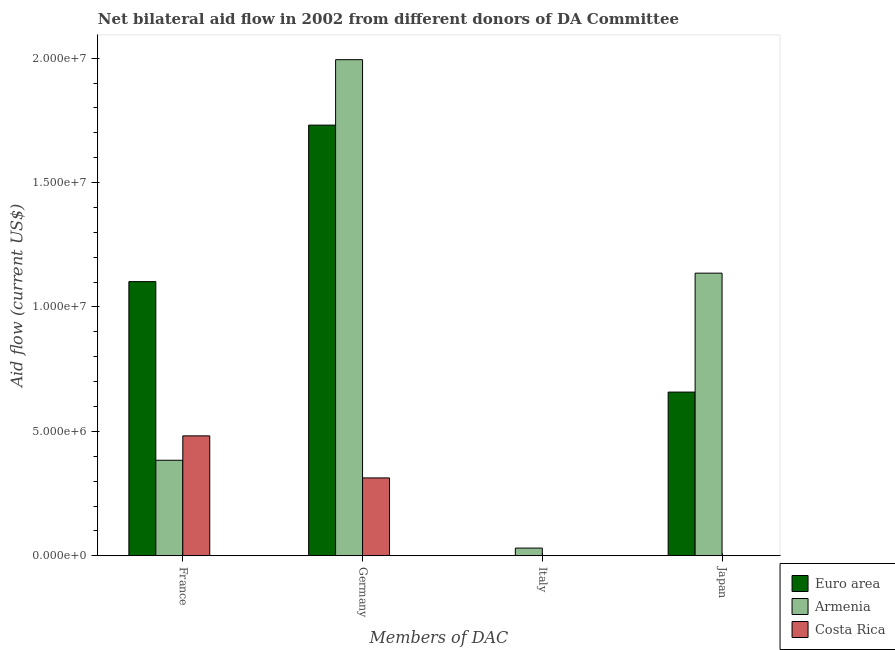How many bars are there on the 3rd tick from the left?
Keep it short and to the point. 1. How many bars are there on the 3rd tick from the right?
Provide a short and direct response. 3. What is the amount of aid given by japan in Euro area?
Provide a succinct answer. 6.58e+06. Across all countries, what is the maximum amount of aid given by japan?
Offer a very short reply. 1.14e+07. In which country was the amount of aid given by japan maximum?
Your answer should be compact. Armenia. What is the total amount of aid given by japan in the graph?
Provide a short and direct response. 1.79e+07. What is the difference between the amount of aid given by germany in Armenia and that in Costa Rica?
Provide a short and direct response. 1.68e+07. What is the difference between the amount of aid given by japan in Armenia and the amount of aid given by france in Costa Rica?
Keep it short and to the point. 6.54e+06. What is the average amount of aid given by japan per country?
Provide a short and direct response. 5.98e+06. What is the difference between the amount of aid given by germany and amount of aid given by japan in Armenia?
Your answer should be compact. 8.58e+06. In how many countries, is the amount of aid given by france greater than 11000000 US$?
Your answer should be very brief. 1. What is the ratio of the amount of aid given by germany in Armenia to that in Euro area?
Offer a very short reply. 1.15. What is the difference between the highest and the second highest amount of aid given by germany?
Provide a succinct answer. 2.63e+06. What is the difference between the highest and the lowest amount of aid given by germany?
Make the answer very short. 1.68e+07. In how many countries, is the amount of aid given by france greater than the average amount of aid given by france taken over all countries?
Your answer should be compact. 1. How many bars are there?
Offer a terse response. 9. Are all the bars in the graph horizontal?
Offer a very short reply. No. Are the values on the major ticks of Y-axis written in scientific E-notation?
Provide a succinct answer. Yes. Where does the legend appear in the graph?
Ensure brevity in your answer.  Bottom right. What is the title of the graph?
Provide a succinct answer. Net bilateral aid flow in 2002 from different donors of DA Committee. Does "Austria" appear as one of the legend labels in the graph?
Provide a short and direct response. No. What is the label or title of the X-axis?
Make the answer very short. Members of DAC. What is the label or title of the Y-axis?
Make the answer very short. Aid flow (current US$). What is the Aid flow (current US$) of Euro area in France?
Ensure brevity in your answer.  1.10e+07. What is the Aid flow (current US$) in Armenia in France?
Offer a very short reply. 3.84e+06. What is the Aid flow (current US$) in Costa Rica in France?
Give a very brief answer. 4.82e+06. What is the Aid flow (current US$) in Euro area in Germany?
Ensure brevity in your answer.  1.73e+07. What is the Aid flow (current US$) in Armenia in Germany?
Make the answer very short. 1.99e+07. What is the Aid flow (current US$) of Costa Rica in Germany?
Give a very brief answer. 3.13e+06. What is the Aid flow (current US$) of Euro area in Italy?
Keep it short and to the point. 0. What is the Aid flow (current US$) of Costa Rica in Italy?
Your answer should be compact. 0. What is the Aid flow (current US$) of Euro area in Japan?
Ensure brevity in your answer.  6.58e+06. What is the Aid flow (current US$) in Armenia in Japan?
Ensure brevity in your answer.  1.14e+07. What is the Aid flow (current US$) in Costa Rica in Japan?
Ensure brevity in your answer.  0. Across all Members of DAC, what is the maximum Aid flow (current US$) in Euro area?
Offer a terse response. 1.73e+07. Across all Members of DAC, what is the maximum Aid flow (current US$) of Armenia?
Offer a terse response. 1.99e+07. Across all Members of DAC, what is the maximum Aid flow (current US$) in Costa Rica?
Provide a short and direct response. 4.82e+06. Across all Members of DAC, what is the minimum Aid flow (current US$) of Euro area?
Your response must be concise. 0. Across all Members of DAC, what is the minimum Aid flow (current US$) in Armenia?
Ensure brevity in your answer.  3.10e+05. Across all Members of DAC, what is the minimum Aid flow (current US$) in Costa Rica?
Provide a short and direct response. 0. What is the total Aid flow (current US$) of Euro area in the graph?
Offer a very short reply. 3.49e+07. What is the total Aid flow (current US$) in Armenia in the graph?
Provide a short and direct response. 3.54e+07. What is the total Aid flow (current US$) in Costa Rica in the graph?
Your answer should be compact. 7.95e+06. What is the difference between the Aid flow (current US$) of Euro area in France and that in Germany?
Your answer should be compact. -6.29e+06. What is the difference between the Aid flow (current US$) of Armenia in France and that in Germany?
Provide a short and direct response. -1.61e+07. What is the difference between the Aid flow (current US$) of Costa Rica in France and that in Germany?
Offer a terse response. 1.69e+06. What is the difference between the Aid flow (current US$) in Armenia in France and that in Italy?
Keep it short and to the point. 3.53e+06. What is the difference between the Aid flow (current US$) in Euro area in France and that in Japan?
Offer a very short reply. 4.44e+06. What is the difference between the Aid flow (current US$) of Armenia in France and that in Japan?
Ensure brevity in your answer.  -7.52e+06. What is the difference between the Aid flow (current US$) in Armenia in Germany and that in Italy?
Make the answer very short. 1.96e+07. What is the difference between the Aid flow (current US$) of Euro area in Germany and that in Japan?
Provide a short and direct response. 1.07e+07. What is the difference between the Aid flow (current US$) in Armenia in Germany and that in Japan?
Make the answer very short. 8.58e+06. What is the difference between the Aid flow (current US$) in Armenia in Italy and that in Japan?
Give a very brief answer. -1.10e+07. What is the difference between the Aid flow (current US$) in Euro area in France and the Aid flow (current US$) in Armenia in Germany?
Offer a very short reply. -8.92e+06. What is the difference between the Aid flow (current US$) in Euro area in France and the Aid flow (current US$) in Costa Rica in Germany?
Ensure brevity in your answer.  7.89e+06. What is the difference between the Aid flow (current US$) in Armenia in France and the Aid flow (current US$) in Costa Rica in Germany?
Offer a terse response. 7.10e+05. What is the difference between the Aid flow (current US$) of Euro area in France and the Aid flow (current US$) of Armenia in Italy?
Offer a very short reply. 1.07e+07. What is the difference between the Aid flow (current US$) of Euro area in France and the Aid flow (current US$) of Armenia in Japan?
Offer a terse response. -3.40e+05. What is the difference between the Aid flow (current US$) in Euro area in Germany and the Aid flow (current US$) in Armenia in Italy?
Make the answer very short. 1.70e+07. What is the difference between the Aid flow (current US$) of Euro area in Germany and the Aid flow (current US$) of Armenia in Japan?
Provide a short and direct response. 5.95e+06. What is the average Aid flow (current US$) of Euro area per Members of DAC?
Make the answer very short. 8.73e+06. What is the average Aid flow (current US$) in Armenia per Members of DAC?
Offer a terse response. 8.86e+06. What is the average Aid flow (current US$) of Costa Rica per Members of DAC?
Make the answer very short. 1.99e+06. What is the difference between the Aid flow (current US$) of Euro area and Aid flow (current US$) of Armenia in France?
Make the answer very short. 7.18e+06. What is the difference between the Aid flow (current US$) in Euro area and Aid flow (current US$) in Costa Rica in France?
Make the answer very short. 6.20e+06. What is the difference between the Aid flow (current US$) in Armenia and Aid flow (current US$) in Costa Rica in France?
Ensure brevity in your answer.  -9.80e+05. What is the difference between the Aid flow (current US$) in Euro area and Aid flow (current US$) in Armenia in Germany?
Make the answer very short. -2.63e+06. What is the difference between the Aid flow (current US$) of Euro area and Aid flow (current US$) of Costa Rica in Germany?
Your answer should be compact. 1.42e+07. What is the difference between the Aid flow (current US$) of Armenia and Aid flow (current US$) of Costa Rica in Germany?
Your answer should be very brief. 1.68e+07. What is the difference between the Aid flow (current US$) of Euro area and Aid flow (current US$) of Armenia in Japan?
Keep it short and to the point. -4.78e+06. What is the ratio of the Aid flow (current US$) in Euro area in France to that in Germany?
Give a very brief answer. 0.64. What is the ratio of the Aid flow (current US$) in Armenia in France to that in Germany?
Your response must be concise. 0.19. What is the ratio of the Aid flow (current US$) of Costa Rica in France to that in Germany?
Offer a very short reply. 1.54. What is the ratio of the Aid flow (current US$) of Armenia in France to that in Italy?
Provide a short and direct response. 12.39. What is the ratio of the Aid flow (current US$) in Euro area in France to that in Japan?
Give a very brief answer. 1.67. What is the ratio of the Aid flow (current US$) in Armenia in France to that in Japan?
Keep it short and to the point. 0.34. What is the ratio of the Aid flow (current US$) of Armenia in Germany to that in Italy?
Your answer should be very brief. 64.32. What is the ratio of the Aid flow (current US$) in Euro area in Germany to that in Japan?
Keep it short and to the point. 2.63. What is the ratio of the Aid flow (current US$) of Armenia in Germany to that in Japan?
Your answer should be compact. 1.76. What is the ratio of the Aid flow (current US$) of Armenia in Italy to that in Japan?
Your answer should be very brief. 0.03. What is the difference between the highest and the second highest Aid flow (current US$) of Euro area?
Give a very brief answer. 6.29e+06. What is the difference between the highest and the second highest Aid flow (current US$) in Armenia?
Ensure brevity in your answer.  8.58e+06. What is the difference between the highest and the lowest Aid flow (current US$) in Euro area?
Provide a succinct answer. 1.73e+07. What is the difference between the highest and the lowest Aid flow (current US$) of Armenia?
Give a very brief answer. 1.96e+07. What is the difference between the highest and the lowest Aid flow (current US$) of Costa Rica?
Offer a very short reply. 4.82e+06. 